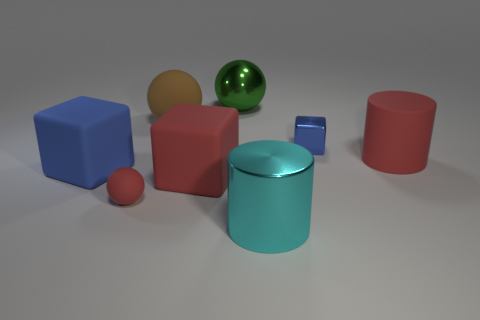There is a red object right of the green thing; what number of big matte objects are in front of it?
Make the answer very short. 2. The big metal thing that is the same shape as the brown rubber object is what color?
Your answer should be very brief. Green. Are the tiny ball and the tiny blue thing made of the same material?
Offer a very short reply. No. What number of balls are either tiny red rubber objects or green metallic things?
Keep it short and to the point. 2. There is a matte object that is to the right of the big red matte thing that is to the left of the blue thing that is to the right of the green object; how big is it?
Keep it short and to the point. Large. The brown matte thing that is the same shape as the green metal object is what size?
Your answer should be compact. Large. How many matte balls are behind the small shiny thing?
Offer a very short reply. 1. There is a rubber block on the left side of the brown matte sphere; is its color the same as the large shiny cylinder?
Make the answer very short. No. How many purple objects are tiny rubber balls or big spheres?
Make the answer very short. 0. There is a cylinder that is on the left side of the small blue object that is behind the large red cube; what is its color?
Ensure brevity in your answer.  Cyan. 